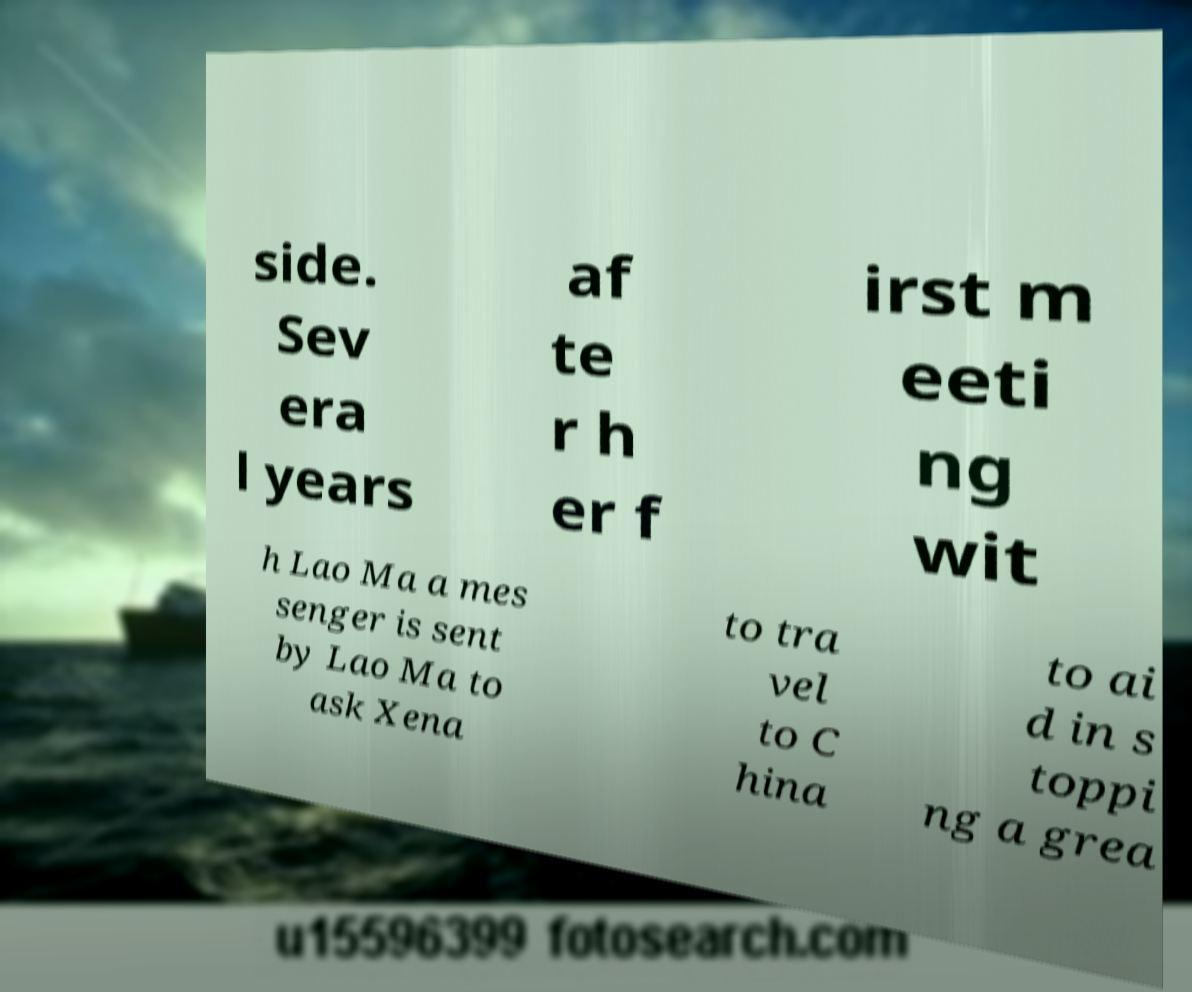I need the written content from this picture converted into text. Can you do that? side. Sev era l years af te r h er f irst m eeti ng wit h Lao Ma a mes senger is sent by Lao Ma to ask Xena to tra vel to C hina to ai d in s toppi ng a grea 